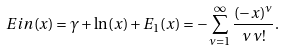<formula> <loc_0><loc_0><loc_500><loc_500>E i n ( x ) = \gamma + \ln ( x ) + E _ { 1 } ( x ) = - \sum _ { \nu = 1 } ^ { \infty } \frac { ( - x ) ^ { \nu } } { \nu \, \nu ! } .</formula> 